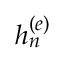Convert formula to latex. <formula><loc_0><loc_0><loc_500><loc_500>h _ { n } ^ { ( e ) }</formula> 